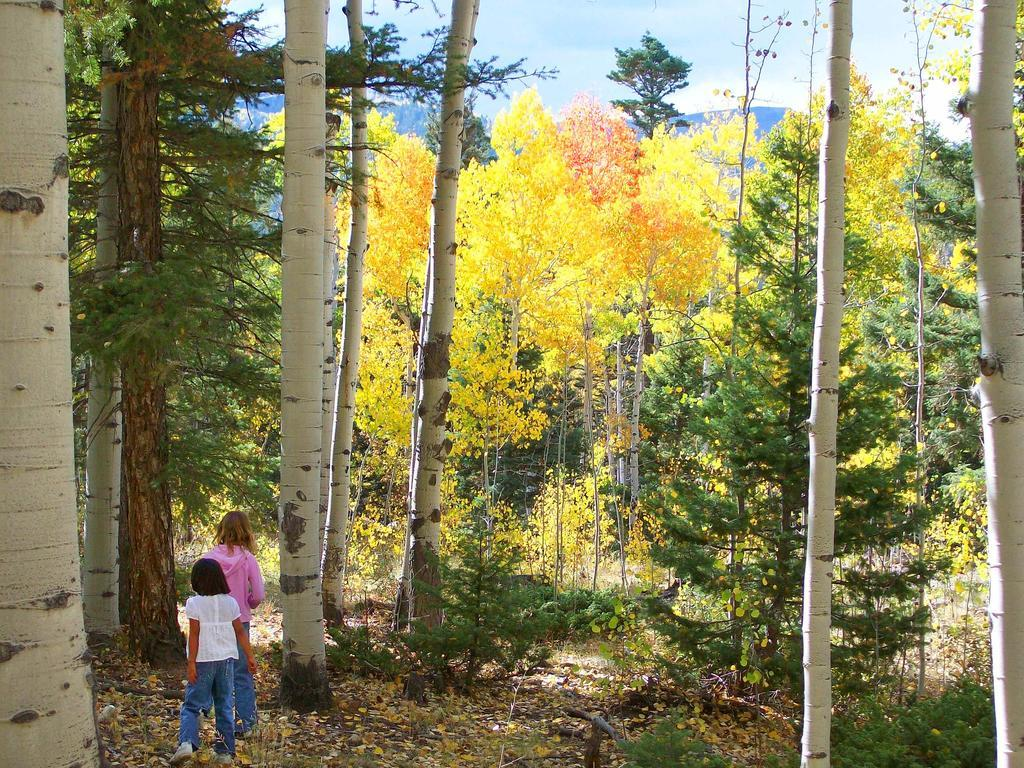Who are the people on the left side of the image? There are two people on the left side of the image. What can be seen in the background of the image? There are trees and the sky visible in the background of the image. What type of beam is holding up the trees in the image? There is no beam present in the image; the trees are standing on their own. 